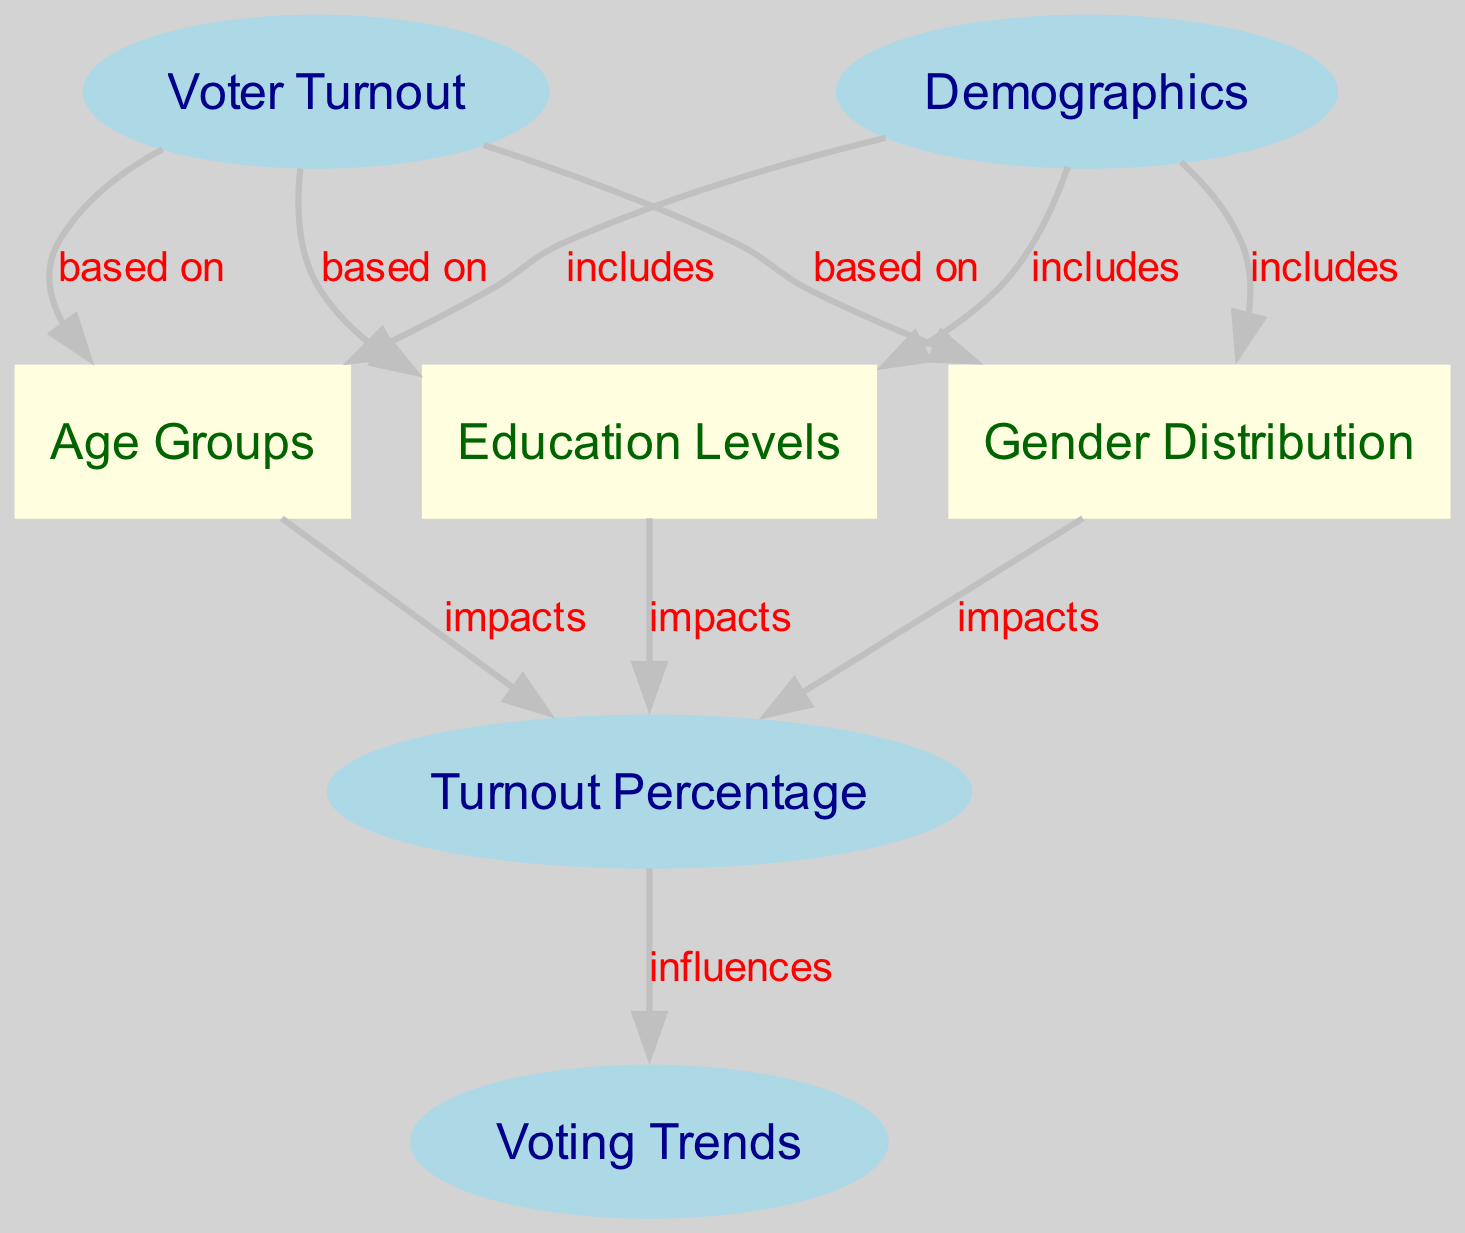What is the primary subject of the diagram? The diagram focuses on "Voter Turnout," which is indicated as the main node connected to various demographic aspects.
Answer: Voter Turnout How many demographics are included in the analysis? The diagram shows three demographic categories: Age Groups, Gender Distribution, and Education Levels, all connected to the Demographics node.
Answer: Three What type of relationship exists between Voter Turnout and Age Groups? The edge between Voter Turnout and Age Groups specifies that Voter Turnout is based on Age Groups, indicating a direct influence of the age demographic on the turnout.
Answer: based on What impact does Gender Distribution have on Turnout Percentage? The diagram indicates that Gender Distribution impacts Turnout Percentage, showing how different gender demographics can affect voter turnout rates.
Answer: impacts How does Turnout Percentage influence Voting Trends? The edge indicates that Turnout Percentage influences Voting Trends, suggesting that the level of voter turnout can affect trends observed in voting behavior.
Answer: influences Which demographic is considered under the Voter Turnout category? The edges point out that Age Groups, Gender Distribution, and Education Levels are all included under the Voter Turnout analysis, marking them as significant categories.
Answer: includes What is the total number of edges in the diagram? Counting the edges connecting the nodes, there are a total of eight edges shown in the diagram that illustrate the relationships between nodes.
Answer: Eight What demographic factors affect the Turnout Percentage? The factors affecting Turnout Percentage are Age Groups, Gender Distribution, and Education Levels, as indicated by the connections to the Turnout Percentage node.
Answer: Age Groups, Gender Distribution, Education Levels What does the direction of the edges in the diagram signify? The directed edges signify causality or influence, indicating how one node may affect another, such as how demographics impact voter turnout percentages.
Answer: Causality or influence 